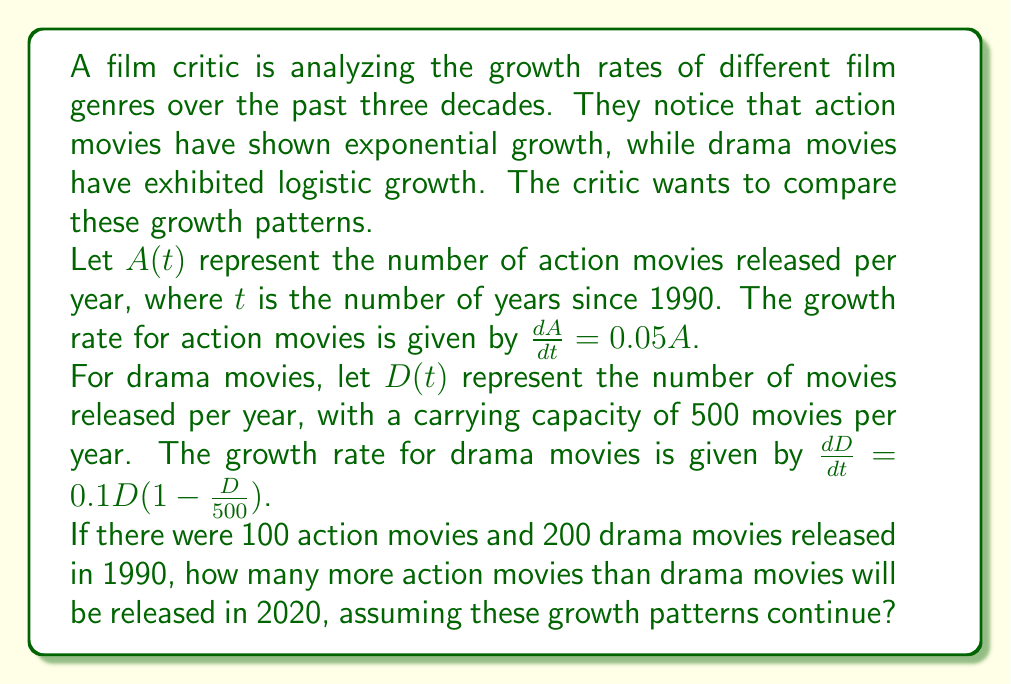Show me your answer to this math problem. To solve this problem, we need to calculate the number of action and drama movies released in 2020 (30 years after 1990) and then find the difference.

1. For action movies (exponential growth):
   The solution to the differential equation $\frac{dA}{dt} = 0.05A$ is:
   $A(t) = A_0e^{0.05t}$
   Where $A_0 = 100$ (initial number of action movies in 1990)
   
   For $t = 30$ (years since 1990):
   $A(30) = 100e^{0.05 \cdot 30} = 100e^{1.5} \approx 448.17$

2. For drama movies (logistic growth):
   The solution to the logistic differential equation $\frac{dD}{dt} = 0.1D(1 - \frac{D}{500})$ is:
   $D(t) = \frac{500}{1 + (\frac{500}{D_0} - 1)e^{-0.1t}}$
   Where $D_0 = 200$ (initial number of drama movies in 1990)
   
   For $t = 30$:
   $D(30) = \frac{500}{1 + (\frac{500}{200} - 1)e^{-0.1 \cdot 30}} \approx 456.62$

3. Difference in number of movies:
   Action movies - Drama movies = $448.17 - 456.62 = -8.45$

The negative result indicates that there will be fewer action movies than drama movies.
Answer: There will be approximately 8 fewer action movies than drama movies released in 2020. 